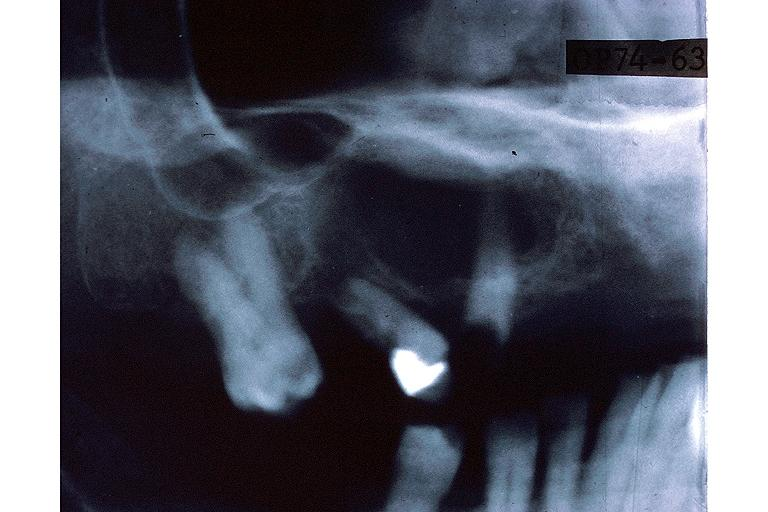does this partially fixed gross show central giant cell lesion?
Answer the question using a single word or phrase. No 